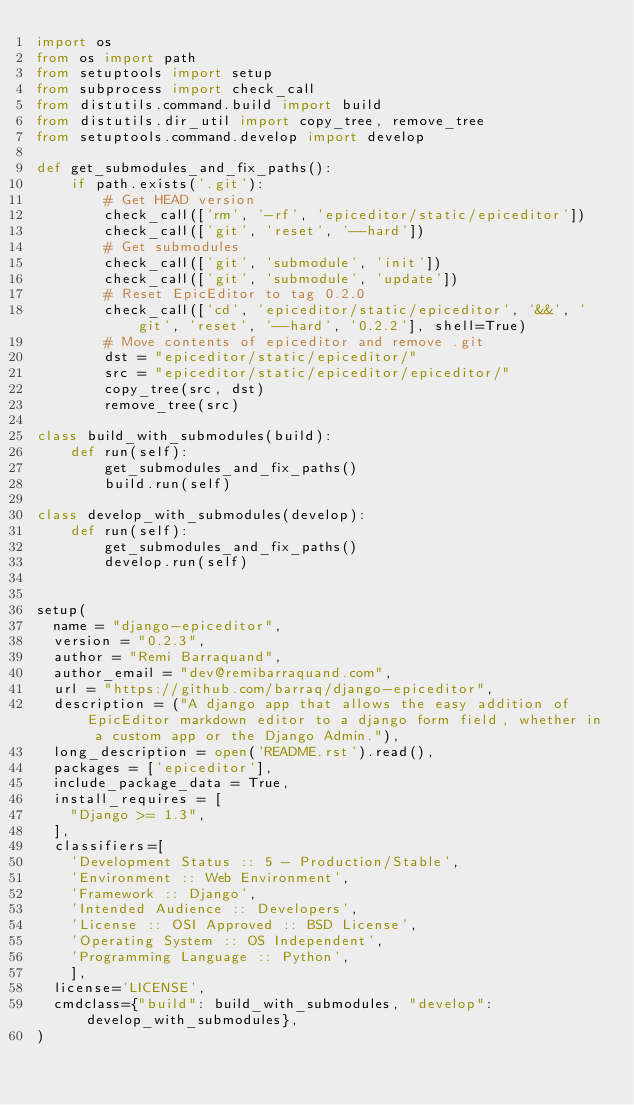Convert code to text. <code><loc_0><loc_0><loc_500><loc_500><_Python_>import os
from os import path
from setuptools import setup
from subprocess import check_call
from distutils.command.build import build
from distutils.dir_util import copy_tree, remove_tree
from setuptools.command.develop import develop

def get_submodules_and_fix_paths():
    if path.exists('.git'):
        # Get HEAD version
        check_call(['rm', '-rf', 'epiceditor/static/epiceditor'])
        check_call(['git', 'reset', '--hard'])
        # Get submodules
        check_call(['git', 'submodule', 'init'])
        check_call(['git', 'submodule', 'update'])
        # Reset EpicEditor to tag 0.2.0
        check_call(['cd', 'epiceditor/static/epiceditor', '&&', 'git', 'reset', '--hard', '0.2.2'], shell=True)
        # Move contents of epiceditor and remove .git
        dst = "epiceditor/static/epiceditor/"
        src = "epiceditor/static/epiceditor/epiceditor/"
        copy_tree(src, dst)
        remove_tree(src)

class build_with_submodules(build):
    def run(self):
        get_submodules_and_fix_paths()
        build.run(self)

class develop_with_submodules(develop):
    def run(self):
        get_submodules_and_fix_paths()
        develop.run(self)


setup(
  name = "django-epiceditor",
  version = "0.2.3",
  author = "Remi Barraquand",
  author_email = "dev@remibarraquand.com",
  url = "https://github.com/barraq/django-epiceditor",
  description = ("A django app that allows the easy addition of EpicEditor markdown editor to a django form field, whether in a custom app or the Django Admin."),
  long_description = open('README.rst').read(),
  packages = ['epiceditor'],
  include_package_data = True,
  install_requires = [
    "Django >= 1.3",
  ],
  classifiers=[
    'Development Status :: 5 - Production/Stable',
    'Environment :: Web Environment',
    'Framework :: Django',
    'Intended Audience :: Developers',
    'License :: OSI Approved :: BSD License',
    'Operating System :: OS Independent',
    'Programming Language :: Python',
    ],
  license='LICENSE',
  cmdclass={"build": build_with_submodules, "develop": develop_with_submodules},
)
</code> 